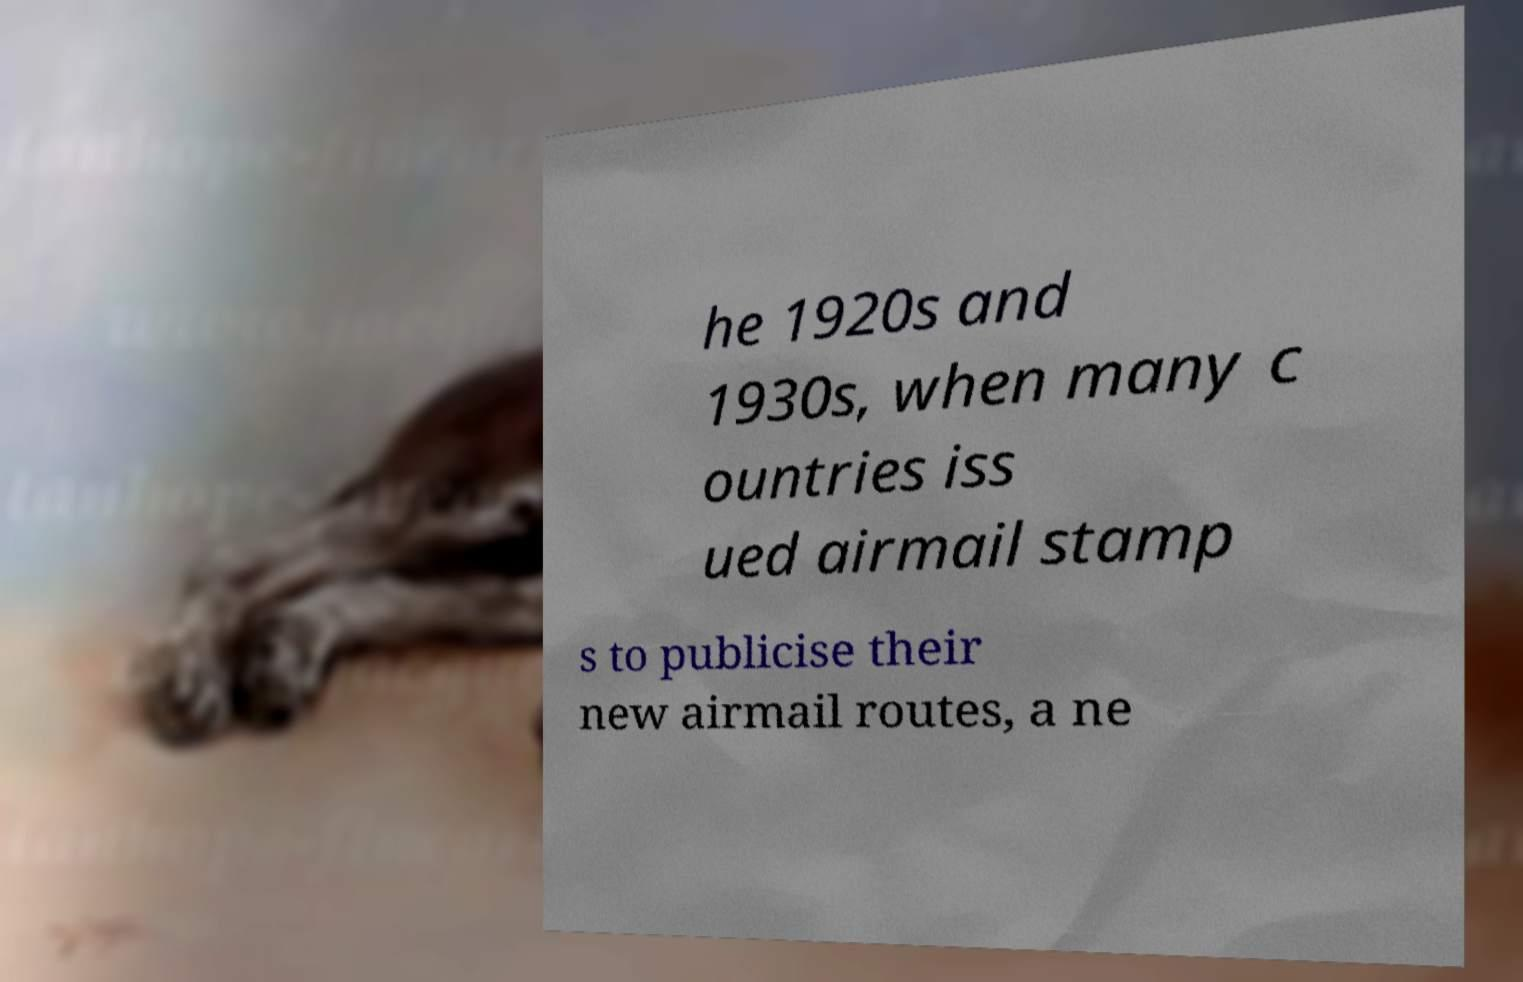There's text embedded in this image that I need extracted. Can you transcribe it verbatim? he 1920s and 1930s, when many c ountries iss ued airmail stamp s to publicise their new airmail routes, a ne 